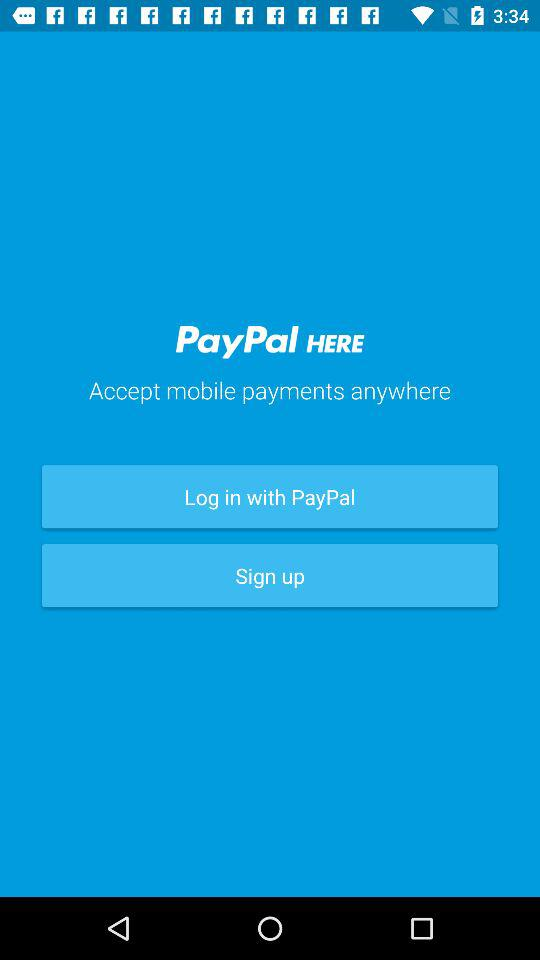Where PayPal accept mobile payment? PayPal accepts payment anywhere. 